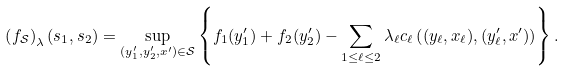<formula> <loc_0><loc_0><loc_500><loc_500>\left ( f _ { \mathcal { S } } \right ) _ { \lambda } ( s _ { 1 } , s _ { 2 } ) = \sup _ { ( y _ { 1 } ^ { \prime } , y _ { 2 } ^ { \prime } , x ^ { \prime } ) \in \mathcal { S } } \left \{ f _ { 1 } ( y _ { 1 } ^ { \prime } ) + f _ { 2 } ( y _ { 2 } ^ { \prime } ) - \sum _ { 1 \leq \ell \leq 2 } \lambda _ { \ell } c _ { \ell } \left ( ( y _ { \ell } , x _ { \ell } ) , ( y ^ { \prime } _ { \ell } , x ^ { \prime } ) \right ) \right \} .</formula> 